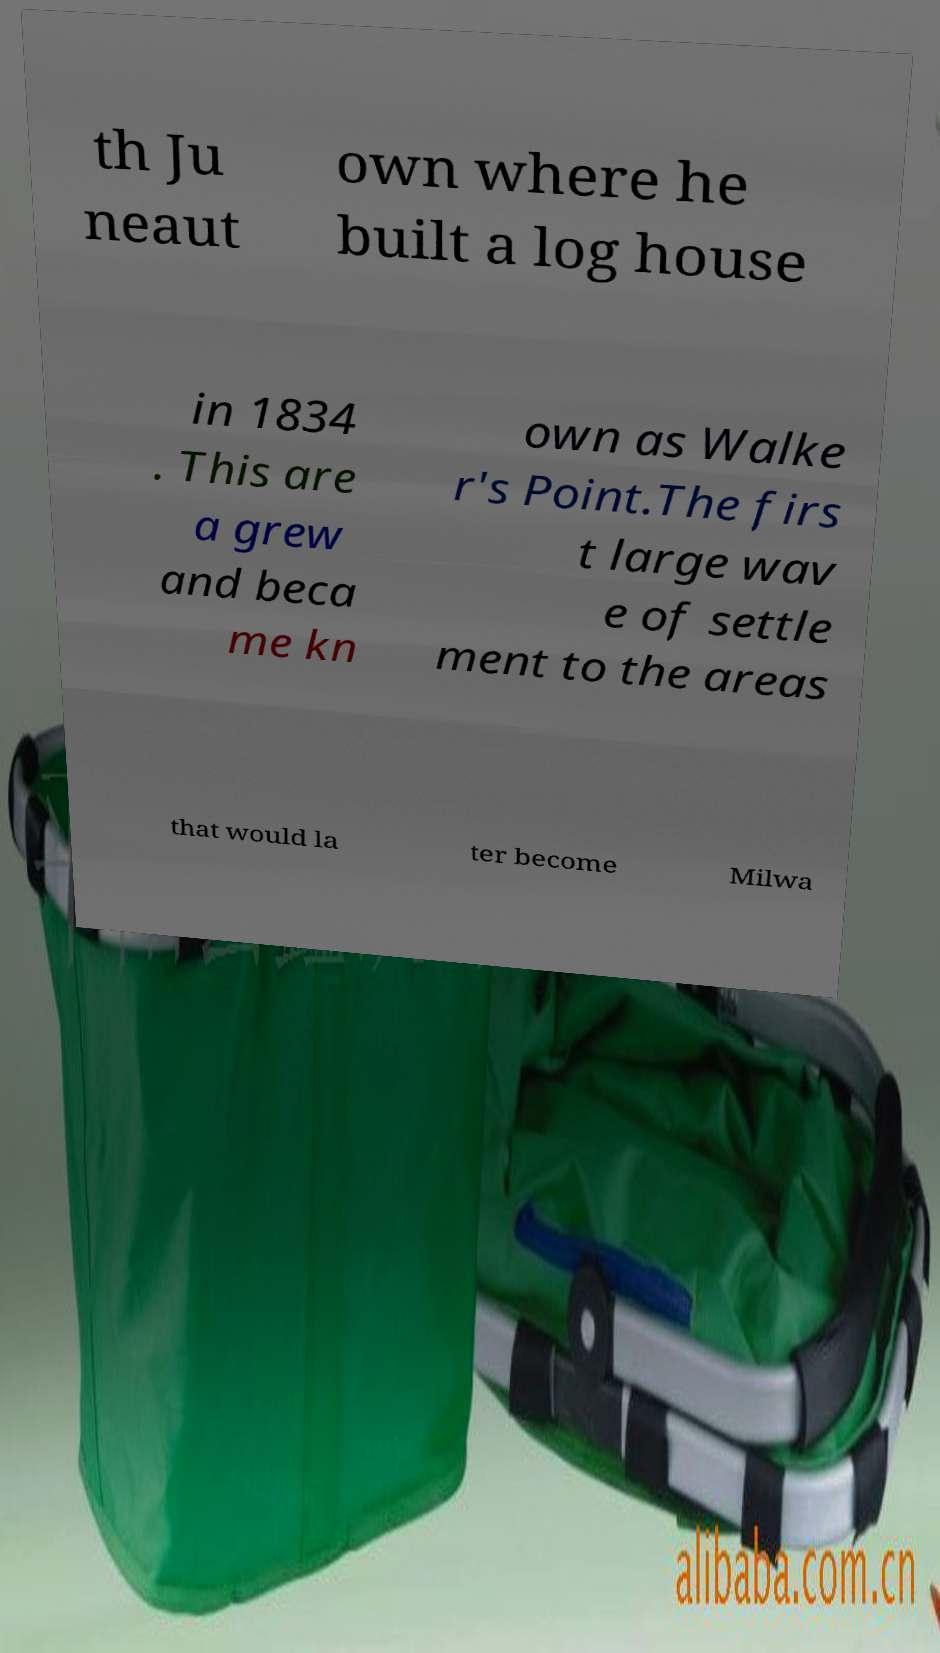Can you accurately transcribe the text from the provided image for me? th Ju neaut own where he built a log house in 1834 . This are a grew and beca me kn own as Walke r's Point.The firs t large wav e of settle ment to the areas that would la ter become Milwa 